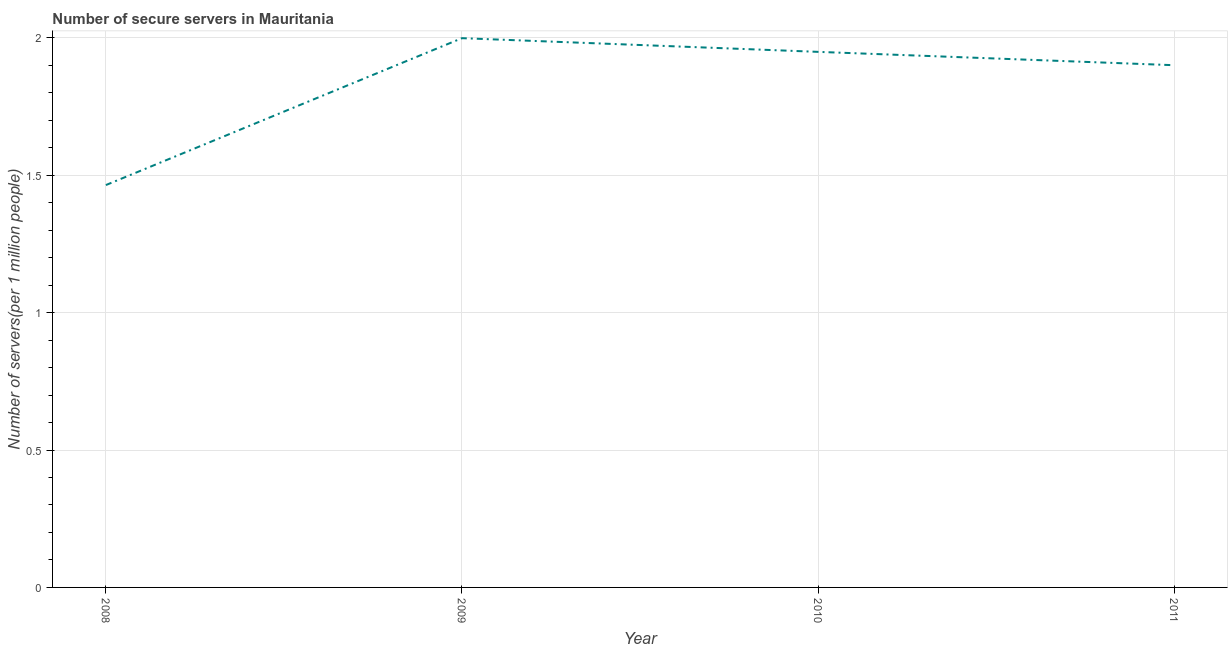What is the number of secure internet servers in 2009?
Your answer should be compact. 2. Across all years, what is the maximum number of secure internet servers?
Ensure brevity in your answer.  2. Across all years, what is the minimum number of secure internet servers?
Provide a short and direct response. 1.46. In which year was the number of secure internet servers maximum?
Keep it short and to the point. 2009. In which year was the number of secure internet servers minimum?
Your response must be concise. 2008. What is the sum of the number of secure internet servers?
Provide a succinct answer. 7.31. What is the difference between the number of secure internet servers in 2008 and 2009?
Make the answer very short. -0.53. What is the average number of secure internet servers per year?
Your answer should be very brief. 1.83. What is the median number of secure internet servers?
Offer a terse response. 1.92. Do a majority of the years between 2009 and 2008 (inclusive) have number of secure internet servers greater than 0.5 ?
Your response must be concise. No. What is the ratio of the number of secure internet servers in 2008 to that in 2010?
Your answer should be very brief. 0.75. What is the difference between the highest and the second highest number of secure internet servers?
Provide a succinct answer. 0.05. Is the sum of the number of secure internet servers in 2008 and 2009 greater than the maximum number of secure internet servers across all years?
Make the answer very short. Yes. What is the difference between the highest and the lowest number of secure internet servers?
Your answer should be very brief. 0.53. In how many years, is the number of secure internet servers greater than the average number of secure internet servers taken over all years?
Offer a very short reply. 3. How many lines are there?
Keep it short and to the point. 1. What is the difference between two consecutive major ticks on the Y-axis?
Provide a short and direct response. 0.5. Does the graph contain any zero values?
Your answer should be very brief. No. What is the title of the graph?
Offer a terse response. Number of secure servers in Mauritania. What is the label or title of the X-axis?
Ensure brevity in your answer.  Year. What is the label or title of the Y-axis?
Keep it short and to the point. Number of servers(per 1 million people). What is the Number of servers(per 1 million people) of 2008?
Make the answer very short. 1.46. What is the Number of servers(per 1 million people) of 2009?
Provide a short and direct response. 2. What is the Number of servers(per 1 million people) of 2010?
Provide a succinct answer. 1.95. What is the Number of servers(per 1 million people) of 2011?
Ensure brevity in your answer.  1.9. What is the difference between the Number of servers(per 1 million people) in 2008 and 2009?
Your answer should be compact. -0.53. What is the difference between the Number of servers(per 1 million people) in 2008 and 2010?
Offer a very short reply. -0.48. What is the difference between the Number of servers(per 1 million people) in 2008 and 2011?
Offer a very short reply. -0.44. What is the difference between the Number of servers(per 1 million people) in 2009 and 2010?
Your answer should be compact. 0.05. What is the difference between the Number of servers(per 1 million people) in 2009 and 2011?
Keep it short and to the point. 0.1. What is the difference between the Number of servers(per 1 million people) in 2010 and 2011?
Provide a short and direct response. 0.05. What is the ratio of the Number of servers(per 1 million people) in 2008 to that in 2009?
Your response must be concise. 0.73. What is the ratio of the Number of servers(per 1 million people) in 2008 to that in 2010?
Make the answer very short. 0.75. What is the ratio of the Number of servers(per 1 million people) in 2008 to that in 2011?
Keep it short and to the point. 0.77. What is the ratio of the Number of servers(per 1 million people) in 2009 to that in 2010?
Your answer should be compact. 1.03. What is the ratio of the Number of servers(per 1 million people) in 2009 to that in 2011?
Provide a short and direct response. 1.05. 